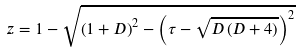Convert formula to latex. <formula><loc_0><loc_0><loc_500><loc_500>z = 1 - \sqrt { \left ( 1 + D \right ) ^ { 2 } - \left ( \tau - \sqrt { D \left ( D + 4 \right ) } \right ) ^ { 2 } }</formula> 